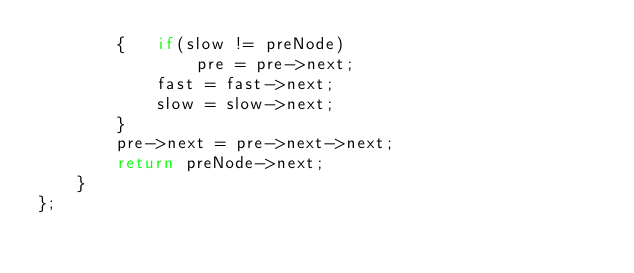<code> <loc_0><loc_0><loc_500><loc_500><_C++_>        {   if(slow != preNode)
                pre = pre->next;
            fast = fast->next;
            slow = slow->next;
        }
        pre->next = pre->next->next;
        return preNode->next;
    }
};

</code> 